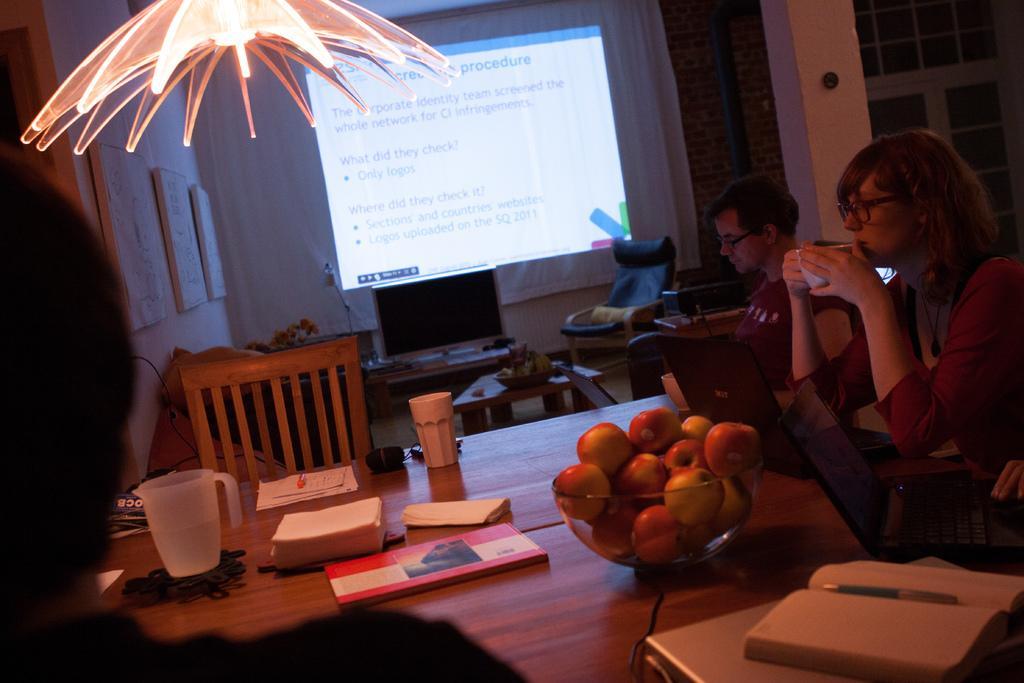Describe this image in one or two sentences. At the bottom of the image there is a table with papers, jug, books, tissues, laptops and also there is a bowl with apples. At the right corner of the image there are two people sitting. In the background there is a table with a monitor, and on the wall there is a screen. At the left corner of the image there is a wall with frames. And at the right corner of the image there is a pole and to the wall there is a window. 